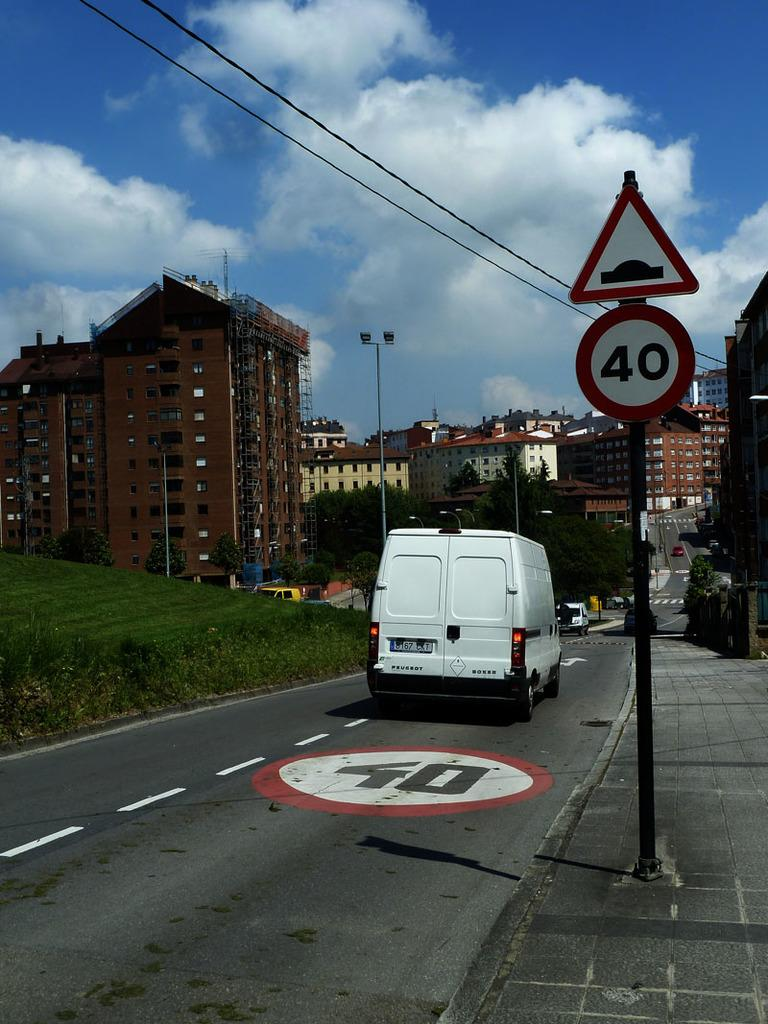<image>
Create a compact narrative representing the image presented. Scenery from a country which includes a van driving on the road with a speed limit sign of 40 kilometers. 